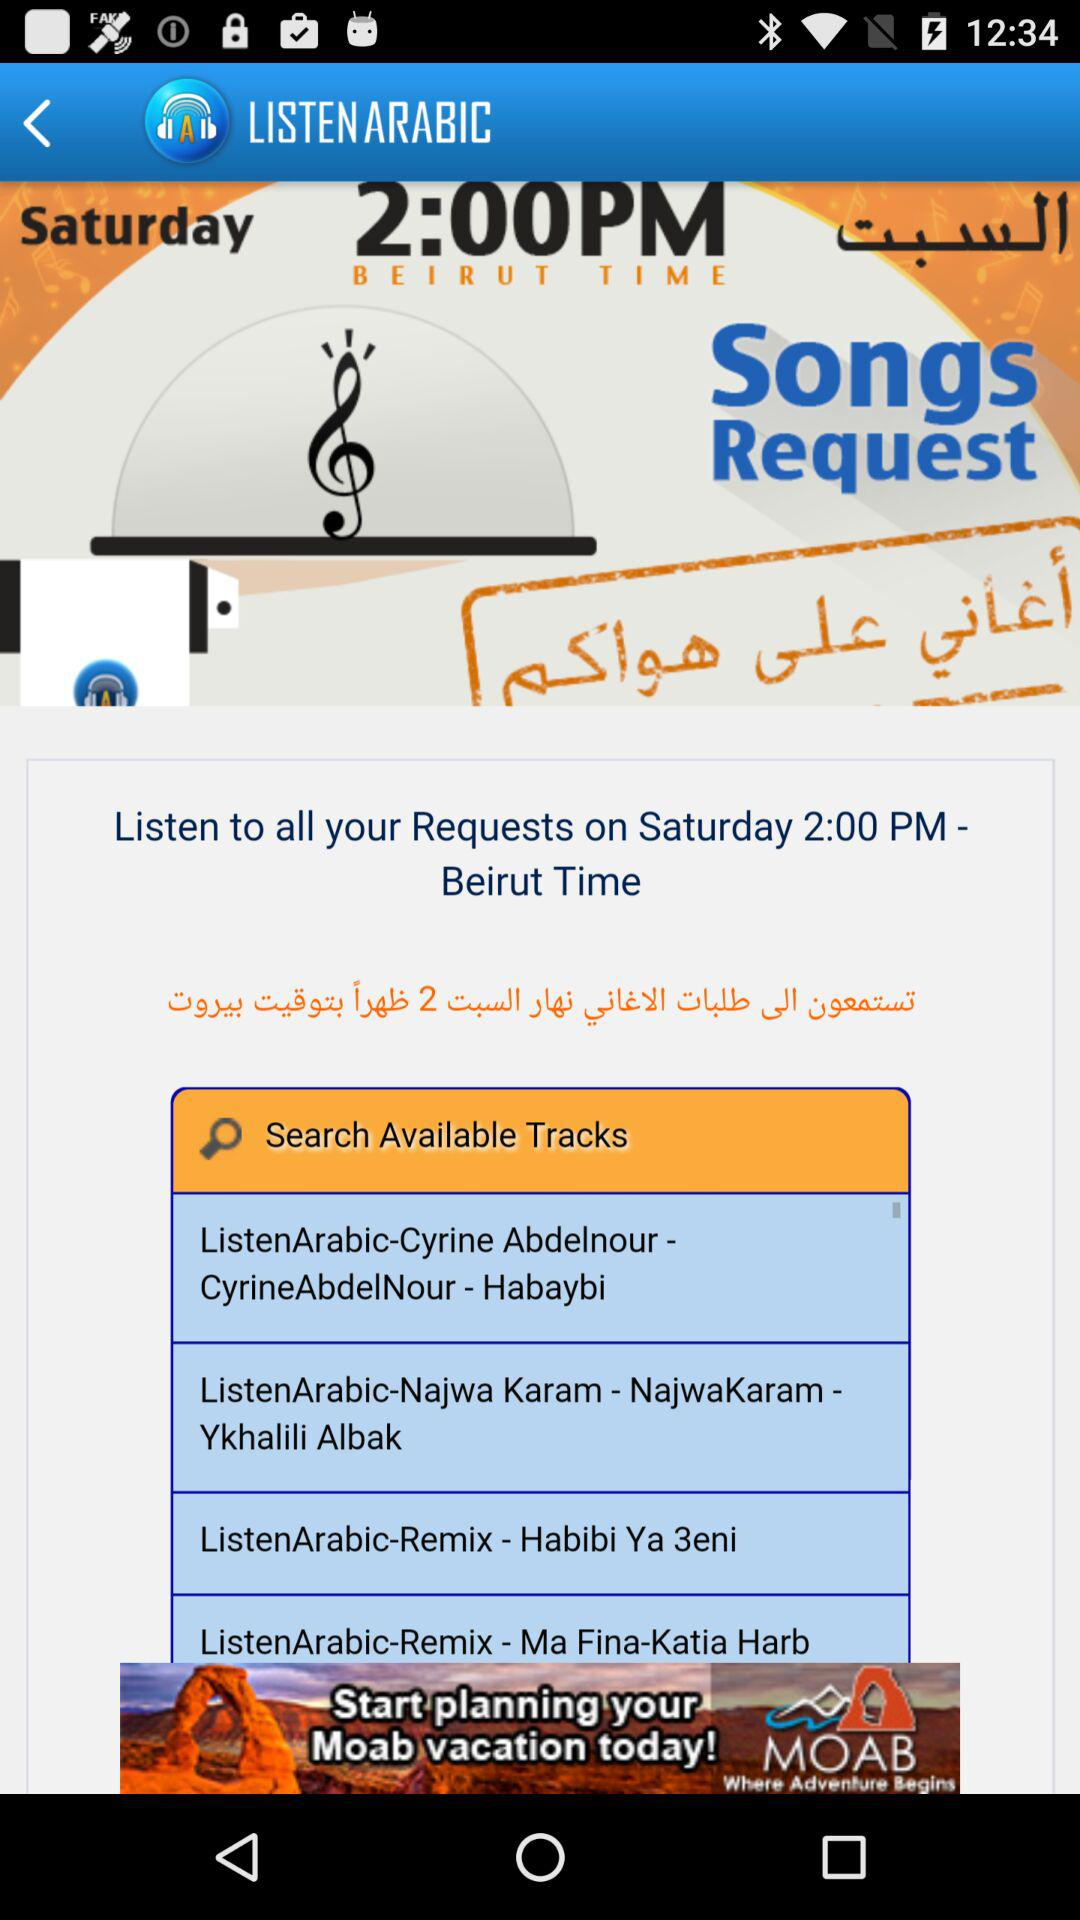What is the day shown on the screen? The day shown on the screen is Saturday. 